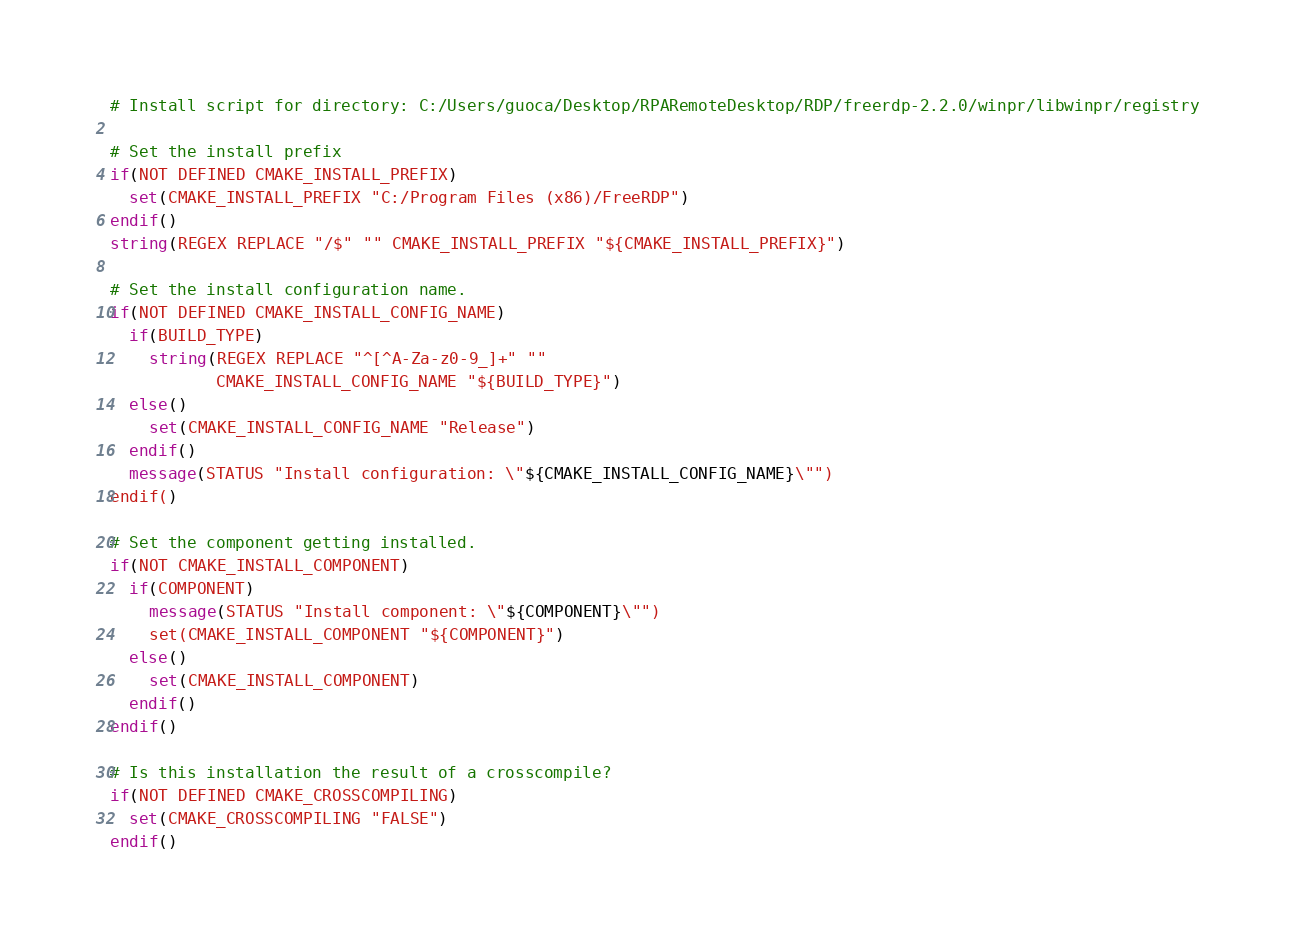<code> <loc_0><loc_0><loc_500><loc_500><_CMake_># Install script for directory: C:/Users/guoca/Desktop/RPARemoteDesktop/RDP/freerdp-2.2.0/winpr/libwinpr/registry

# Set the install prefix
if(NOT DEFINED CMAKE_INSTALL_PREFIX)
  set(CMAKE_INSTALL_PREFIX "C:/Program Files (x86)/FreeRDP")
endif()
string(REGEX REPLACE "/$" "" CMAKE_INSTALL_PREFIX "${CMAKE_INSTALL_PREFIX}")

# Set the install configuration name.
if(NOT DEFINED CMAKE_INSTALL_CONFIG_NAME)
  if(BUILD_TYPE)
    string(REGEX REPLACE "^[^A-Za-z0-9_]+" ""
           CMAKE_INSTALL_CONFIG_NAME "${BUILD_TYPE}")
  else()
    set(CMAKE_INSTALL_CONFIG_NAME "Release")
  endif()
  message(STATUS "Install configuration: \"${CMAKE_INSTALL_CONFIG_NAME}\"")
endif()

# Set the component getting installed.
if(NOT CMAKE_INSTALL_COMPONENT)
  if(COMPONENT)
    message(STATUS "Install component: \"${COMPONENT}\"")
    set(CMAKE_INSTALL_COMPONENT "${COMPONENT}")
  else()
    set(CMAKE_INSTALL_COMPONENT)
  endif()
endif()

# Is this installation the result of a crosscompile?
if(NOT DEFINED CMAKE_CROSSCOMPILING)
  set(CMAKE_CROSSCOMPILING "FALSE")
endif()

</code> 